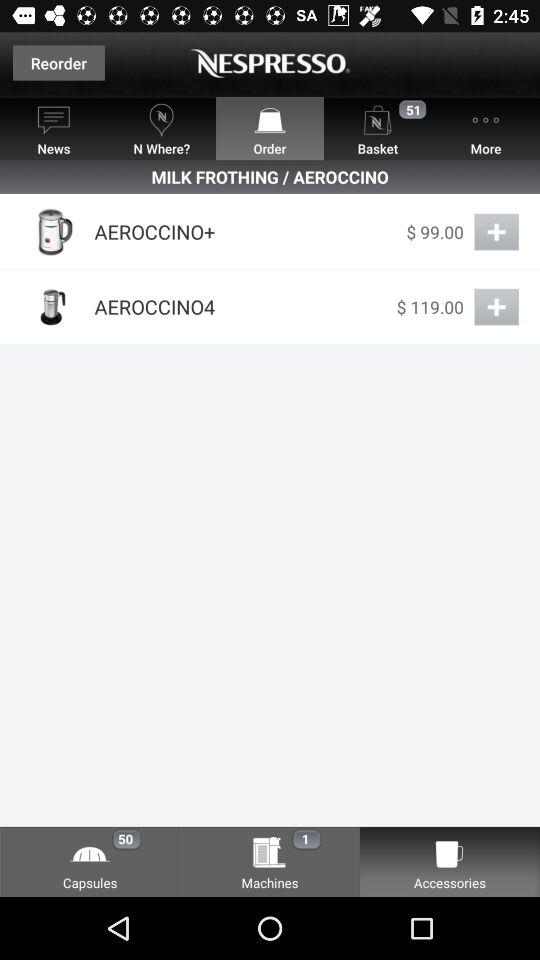What is the price of "AEROCCINO+"? The price of "AEROCCINO+" is $99.00. 